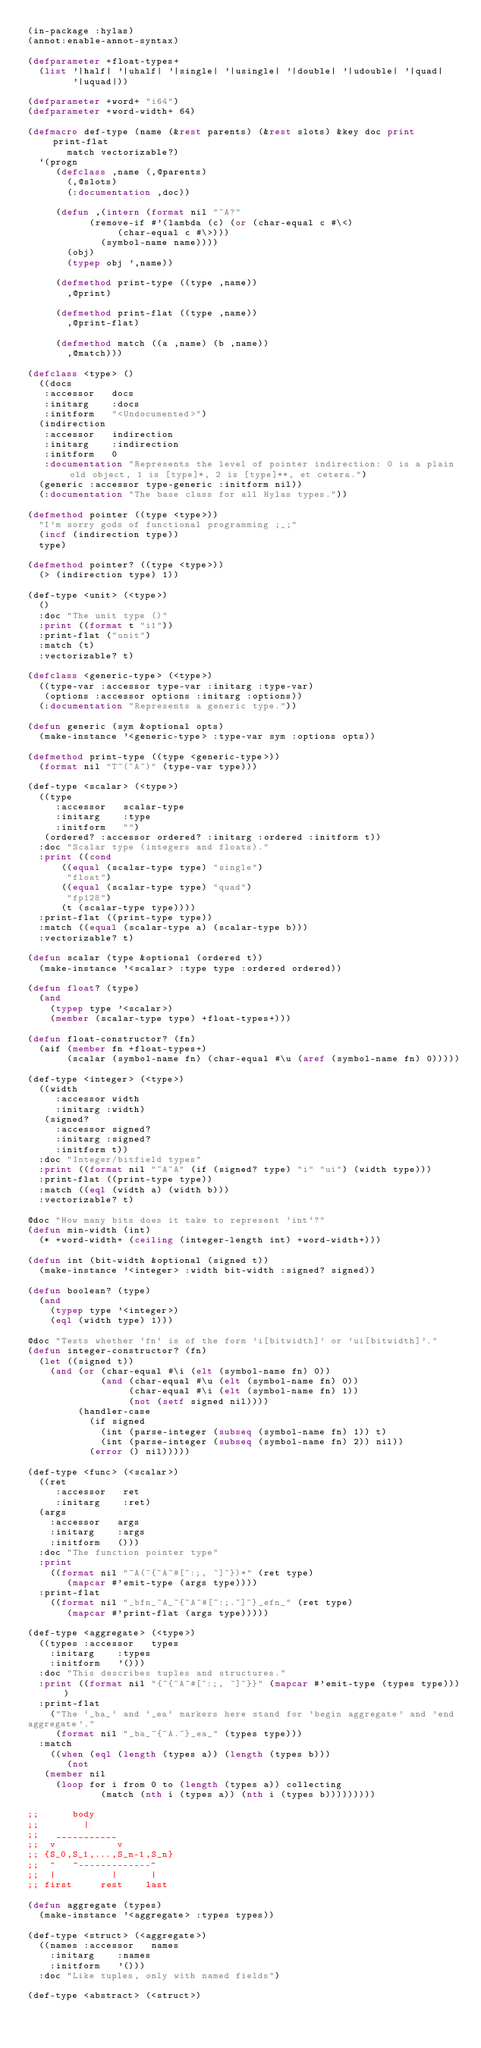<code> <loc_0><loc_0><loc_500><loc_500><_Lisp_>(in-package :hylas)
(annot:enable-annot-syntax)

(defparameter +float-types+
  (list '|half| '|uhalf| '|single| '|usingle| '|double| '|udouble| '|quad|
        '|uquad|))

(defparameter +word+ "i64")
(defparameter +word-width+ 64)

(defmacro def-type (name (&rest parents) (&rest slots) &key doc print print-flat
		   match vectorizable?)
  `(progn
     (defclass ,name (,@parents)
       (,@slots)
       (:documentation ,doc))
     
     (defun ,(intern (format nil "~A?"
		       (remove-if #'(lambda (c) (or (char-equal c #\<)
						    (char-equal c #\>)))
		         (symbol-name name))))
       (obj)
       (typep obj ',name))

     (defmethod print-type ((type ,name))
       ,@print)

     (defmethod print-flat ((type ,name))
       ,@print-flat)

     (defmethod match ((a ,name) (b ,name))
       ,@match)))

(defclass <type> ()
  ((docs
   :accessor   docs
   :initarg    :docs
   :initform   "<Undocumented>")
  (indirection
   :accessor   indirection
   :initarg    :indirection
   :initform   0
   :documentation "Represents the level of pointer indirection: 0 is a plain old object, 1 is [type]*, 2 is [type]**, et cetera.")
  (generic :accessor type-generic :initform nil))
  (:documentation "The base class for all Hylas types."))

(defmethod pointer ((type <type>))
  "I'm sorry gods of functional programming ;_;"
  (incf (indirection type))
  type)

(defmethod pointer? ((type <type>))
  (> (indirection type) 1))

(def-type <unit> (<type>)
  ()
  :doc "The unit type ()"
  :print ((format t "i1"))
  :print-flat ("unit")
  :match (t)
  :vectorizable? t)

(defclass <generic-type> (<type>)
  ((type-var :accessor type-var :initarg :type-var)
   (options :accessor options :initarg :options))
  (:documentation "Represents a generic type."))

(defun generic (sym &optional opts)
  (make-instance '<generic-type> :type-var sym :options opts))

(defmethod print-type ((type <generic-type>))
  (format nil "T~(~A~)" (type-var type)))

(def-type <scalar> (<type>)
  ((type
     :accessor   scalar-type
     :initarg    :type
     :initform   "")
   (ordered? :accessor ordered? :initarg :ordered :initform t))
  :doc "Scalar type (integers and floats)."
  :print ((cond
	    ((equal (scalar-type type) "single")
	     "float")
	    ((equal (scalar-type type) "quad")
	     "fp128")
	    (t (scalar-type type))))
  :print-flat ((print-type type))
  :match ((equal (scalar-type a) (scalar-type b)))
  :vectorizable? t)

(defun scalar (type &optional (ordered t))
  (make-instance '<scalar> :type type :ordered ordered))

(defun float? (type)
  (and
    (typep type '<scalar>)
    (member (scalar-type type) +float-types+)))

(defun float-constructor? (fn)
  (aif (member fn +float-types+)
       (scalar (symbol-name fn) (char-equal #\u (aref (symbol-name fn) 0)))))

(def-type <integer> (<type>)
  ((width
     :accessor width
     :initarg :width)
   (signed?
     :accessor signed?
     :initarg :signed?
     :initform t))
  :doc "Integer/bitfield types"
  :print ((format nil "~A~A" (if (signed? type) "i" "ui") (width type)))
  :print-flat ((print-type type))
  :match ((eql (width a) (width b)))
  :vectorizable? t)

@doc "How many bits does it take to represent `int`?"
(defun min-width (int)
  (* +word-width+ (ceiling (integer-length int) +word-width+)))

(defun int (bit-width &optional (signed t))
  (make-instance '<integer> :width bit-width :signed? signed))

(defun boolean? (type)
  (and
    (typep type '<integer>)
    (eql (width type) 1)))

@doc "Tests whether `fn` is of the form 'i[bitwidth]' or 'ui[bitwidth]'."
(defun integer-constructor? (fn)
  (let ((signed t))
    (and (or (char-equal #\i (elt (symbol-name fn) 0))
             (and (char-equal #\u (elt (symbol-name fn) 0))
                  (char-equal #\i (elt (symbol-name fn) 1))
                  (not (setf signed nil))))
         (handler-case
           (if signed
             (int (parse-integer (subseq (symbol-name fn) 1)) t)
             (int (parse-integer (subseq (symbol-name fn) 2)) nil))
           (error () nil)))))

(def-type <func> (<scalar>)
  ((ret
     :accessor   ret
     :initarg    :ret)
  (args
    :accessor   args
    :initarg    :args
    :initform   ()))
  :doc "The function pointer type"
  :print
    ((format nil "~A(~{~A~#[~:;, ~]~})*" (ret type)
       (mapcar #'emit-type (args type))))
  :print-flat
    ((format nil "_bfn_~A_~{~A~#[~:;.~]~}_efn_" (ret type)
       (mapcar #'print-flat (args type)))))

(def-type <aggregate> (<type>)
  ((types :accessor   types
    :initarg    :types
    :initform   '()))
  :doc "This describes tuples and structures."
  :print ((format nil "{~{~A~#[~:;, ~]~}}" (mapcar #'emit-type (types type))))
  :print-flat
    ("The `_ba_` and `_ea` markers here stand for 'begin aggregate' and 'end
aggregate'."
     (format nil "_ba_~{~A.~}_ea_" (types type)))
  :match
    ((when (eql (length (types a)) (length (types b)))
       (not
	 (member nil
	   (loop for i from 0 to (length (types a)) collecting
             (match (nth i (types a)) (nth i (types b)))))))))

;;      body
;;        |
;;   ___________
;;  v           v
;; {S_0,S_1,...,S_n-1,S_n}
;;  ^   ^-------------^
;;  |          |      |
;; first     rest    last

(defun aggregate (types)
  (make-instance '<aggregate> :types types))

(def-type <struct> (<aggregate>)
  ((names :accessor   names
    :initarg    :names
    :initform   '()))
  :doc "Like tuples, only with named fields")

(def-type <abstract> (<struct>)</code> 